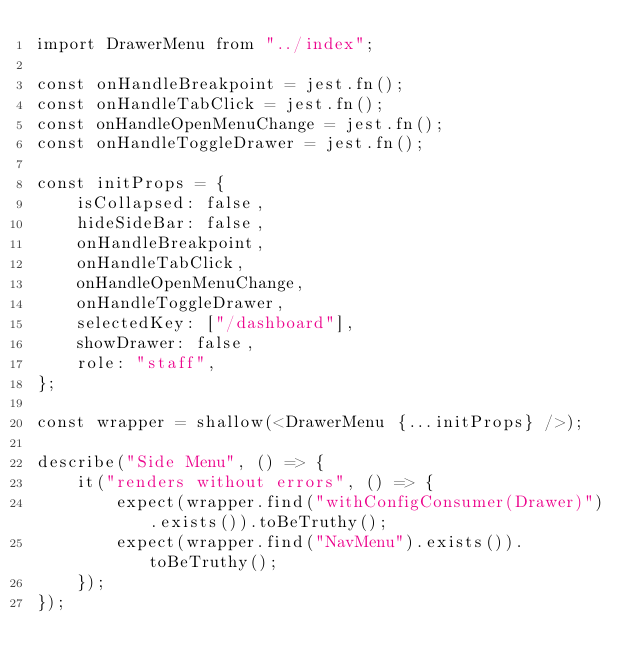Convert code to text. <code><loc_0><loc_0><loc_500><loc_500><_JavaScript_>import DrawerMenu from "../index";

const onHandleBreakpoint = jest.fn();
const onHandleTabClick = jest.fn();
const onHandleOpenMenuChange = jest.fn();
const onHandleToggleDrawer = jest.fn();

const initProps = {
	isCollapsed: false,
	hideSideBar: false,
	onHandleBreakpoint,
	onHandleTabClick,
	onHandleOpenMenuChange,
	onHandleToggleDrawer,
	selectedKey: ["/dashboard"],
	showDrawer: false,
	role: "staff",
};

const wrapper = shallow(<DrawerMenu {...initProps} />);

describe("Side Menu", () => {
	it("renders without errors", () => {
		expect(wrapper.find("withConfigConsumer(Drawer)").exists()).toBeTruthy();
		expect(wrapper.find("NavMenu").exists()).toBeTruthy();
	});
});
</code> 